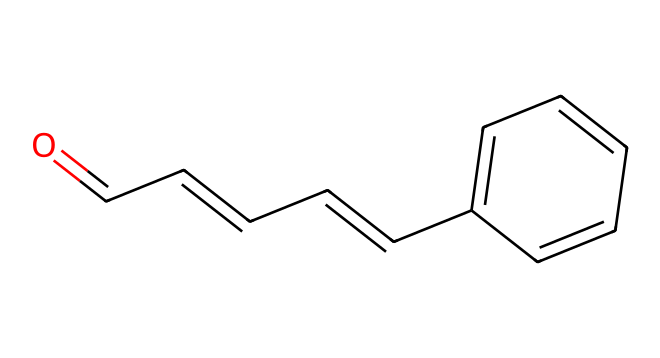How many carbon atoms are in cinnamaldehyde? In the provided SMILES representation, "O=CC=CC=Cc1ccccc1", we can count the carbon atoms by identifying each 'C'. There are 9 carbon atoms total, contributing to the backbone of the molecule.
Answer: 9 What functional group is present in cinnamaldehyde? Looking at the SMILES, the presence of the carbonyl group (C=O) at the beginning, indicated by "O=", signifies that it contains an aldehyde functional group.
Answer: aldehyde How many double bonds are present in cinnamaldehyde? In the structure represented by the SMILES, we can see three double bonds: one between the carbonyl carbon and oxygen, and two within the carbon chain. Therefore, the total number of double bonds is three.
Answer: 3 What is the IUPAC name for the compound represented by the SMILES? The SMILES notation indicates that the compound has both a long-chain aliphatic part and a phenyl group. Taking these into account, the IUPAC name derived from the structure is cinnamaldehyde.
Answer: cinnamaldehyde Is cinnamaldehyde polar or nonpolar? The presence of the polar carbonyl group (C=O) within the structure indicates that it possesses polar characteristics, despite having nonpolar components. This results in an overall polar nature.
Answer: polar What is the molecular formula of cinnamaldehyde? To derive the molecular formula from the SMILES, we count the atoms: 9 carbon (C), 8 hydrogen (H), and 1 oxygen (O). Thus, the molecular formula is C9H8O.
Answer: C9H8O Does cinnamaldehyde contain an aromatic ring? The notation "c" in the SMILES indicates the presence of aromatic carbon atoms, connected in a cyclical manner, which validates that there is an aromatic ring in cinnamaldehyde.
Answer: yes 